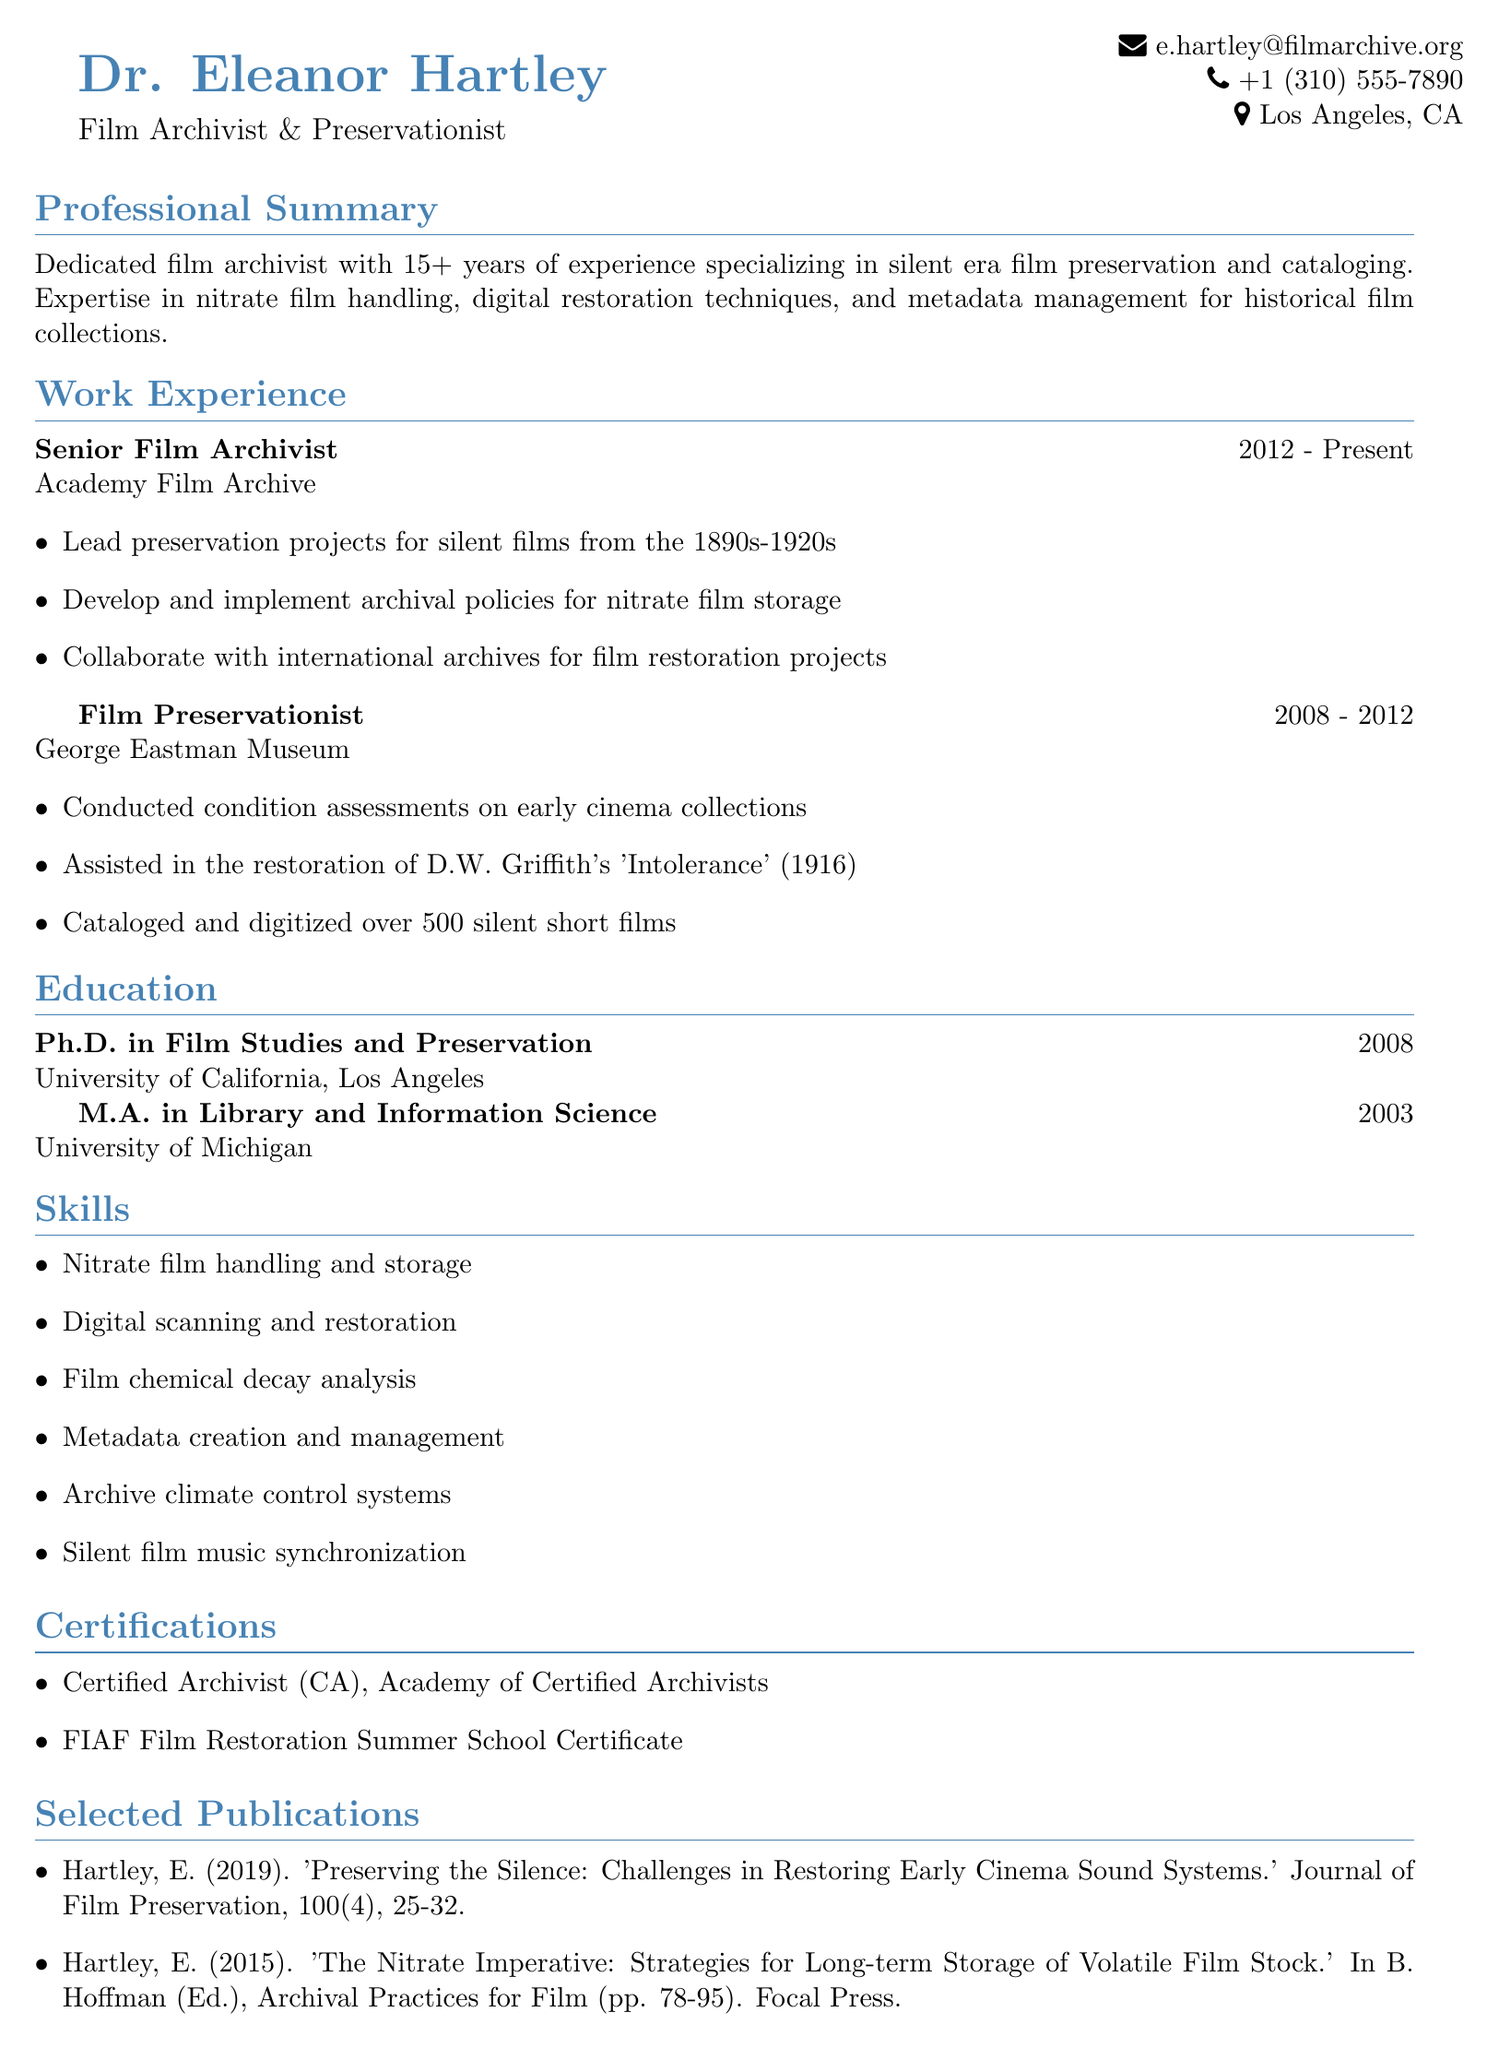What is the name of the archivist? The name of the archivist is listed at the top of the document.
Answer: Dr. Eleanor Hartley What is the highest degree earned by Dr. Hartley? The highest degree is mentioned in the education section of the document.
Answer: Ph.D. in Film Studies and Preservation In which year did Dr. Hartley complete her M.A. degree? The year can be found in the education section next to the degree.
Answer: 2003 How many years of experience does Dr. Hartley have? The total years of experience is mentioned in the professional summary.
Answer: 15+ What is one of Dr. Hartley's key responsibilities as a Senior Film Archivist? This can be found under the work experience section which outlines her responsibilities.
Answer: Lead preservation projects for silent films from the 1890s-1920s Which certification is obtained from the Academy of Certified Archivists? This certification is listed under the certifications section of the document.
Answer: Certified Archivist (CA) What publication discusses early cinema sound systems? The publications section lists works authored by Dr. Hartley where this title can be found.
Answer: Preserving the Silence: Challenges in Restoring Early Cinema Sound Systems What type of films does Dr. Hartley specialize in preserving? The professional summary outlines her area of expertise.
Answer: Silent era films How long did Dr. Hartley work at the George Eastman Museum? The duration of employment is specified under her work experience section.
Answer: 4 years 